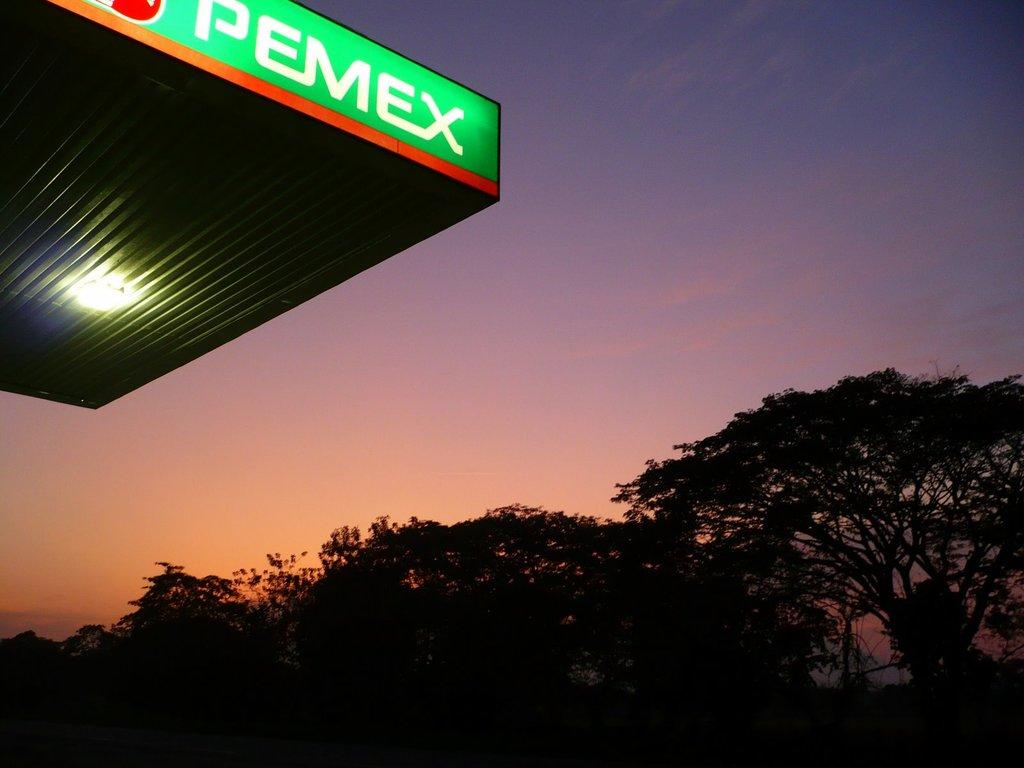What type of vegetation can be seen in the background of the image? There are trees in the background of the image. What part of the natural environment is visible in the image? The sky is visible in the image. Where can lights be found in the image? There is a ceiling with lights on the left side of the image. Can you see any caves in the image? There is no cave present in the image. What type of yoke is being used by the trees in the image? There are no yokes present in the image, as yokes are typically associated with animals or vehicles, not trees. 